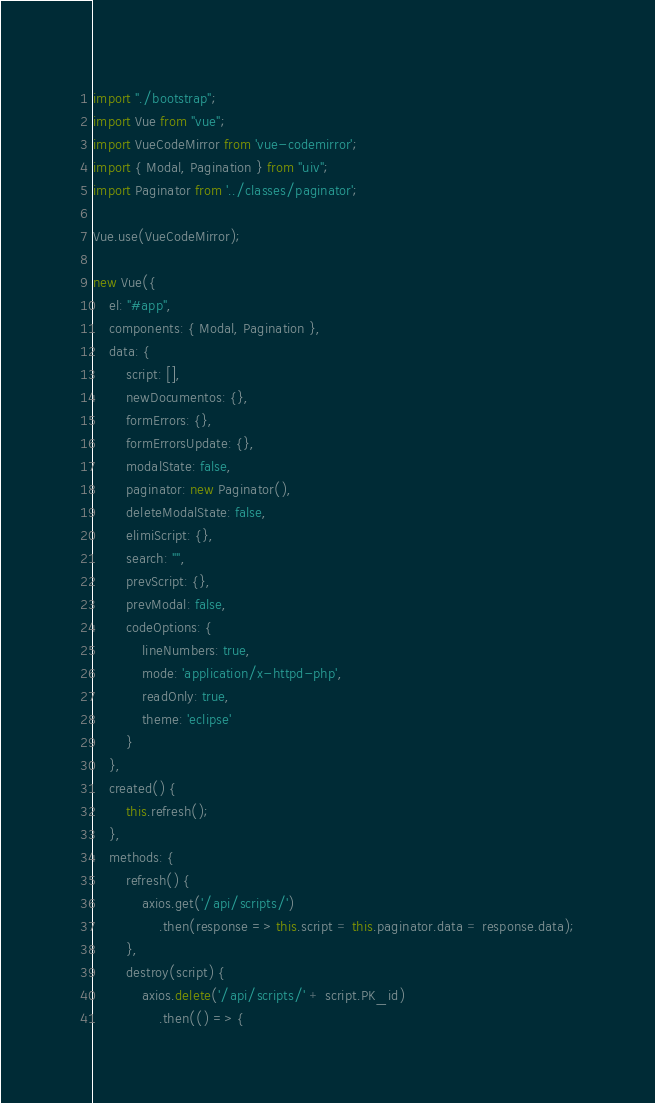<code> <loc_0><loc_0><loc_500><loc_500><_JavaScript_>import "./bootstrap";
import Vue from "vue";
import VueCodeMirror from 'vue-codemirror';
import { Modal, Pagination } from "uiv";
import Paginator from '../classes/paginator';

Vue.use(VueCodeMirror);

new Vue({
    el: "#app",
    components: { Modal, Pagination },
    data: {
        script: [],
        newDocumentos: {},
        formErrors: {},
        formErrorsUpdate: {},
        modalState: false,
        paginator: new Paginator(),
        deleteModalState: false,
        elimiScript: {},
        search: "",
        prevScript: {},
        prevModal: false,
        codeOptions: {
            lineNumbers: true,
            mode: 'application/x-httpd-php',
            readOnly: true,
            theme: 'eclipse'
        }
    },
    created() {
        this.refresh();
    },
    methods: {
        refresh() {
            axios.get('/api/scripts/')
                .then(response => this.script = this.paginator.data = response.data);
        },
        destroy(script) {
            axios.delete('/api/scripts/' + script.PK_id)
                .then(() => {</code> 